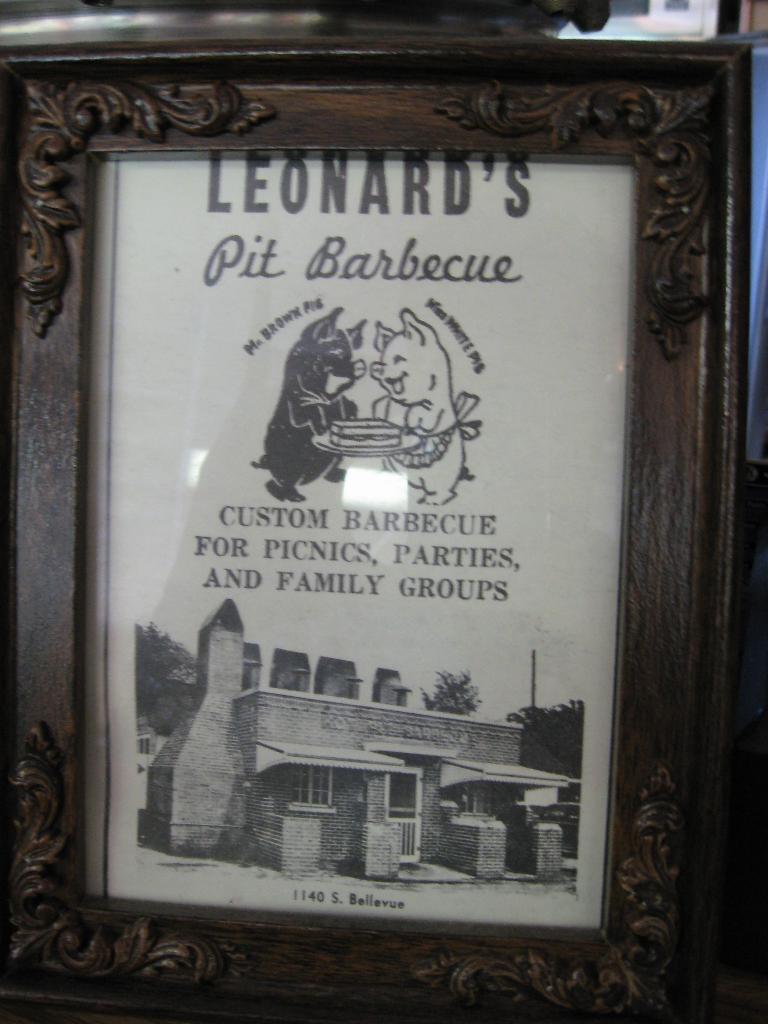Can you describe this image briefly? In this image I can see the frame. In the frame I can see the building, tree and the sky. I can see something is written in the frame. 